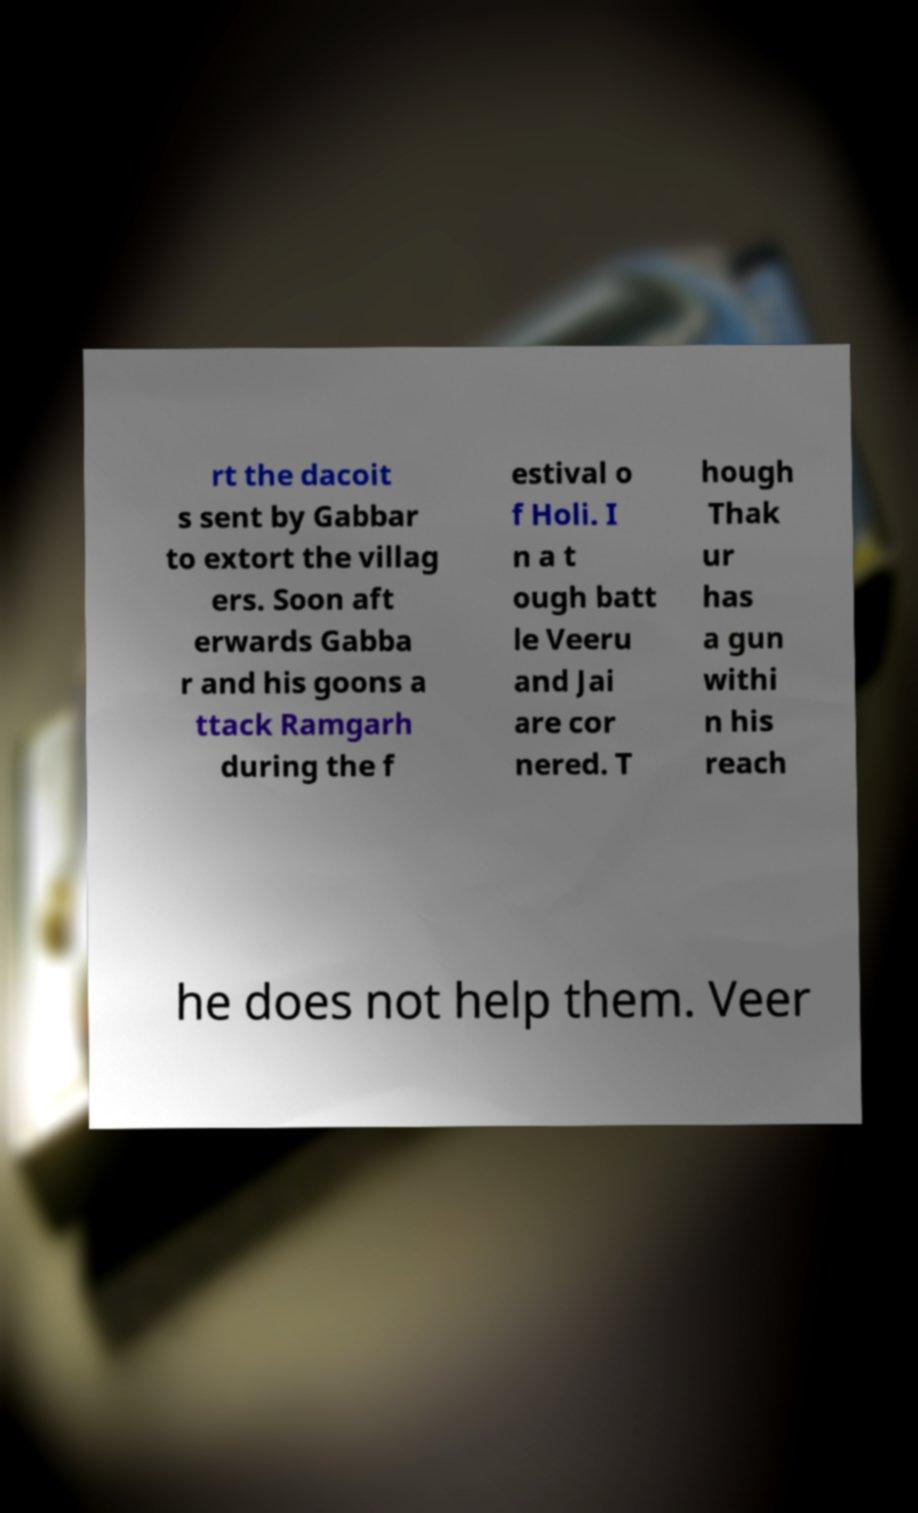Please read and relay the text visible in this image. What does it say? rt the dacoit s sent by Gabbar to extort the villag ers. Soon aft erwards Gabba r and his goons a ttack Ramgarh during the f estival o f Holi. I n a t ough batt le Veeru and Jai are cor nered. T hough Thak ur has a gun withi n his reach he does not help them. Veer 